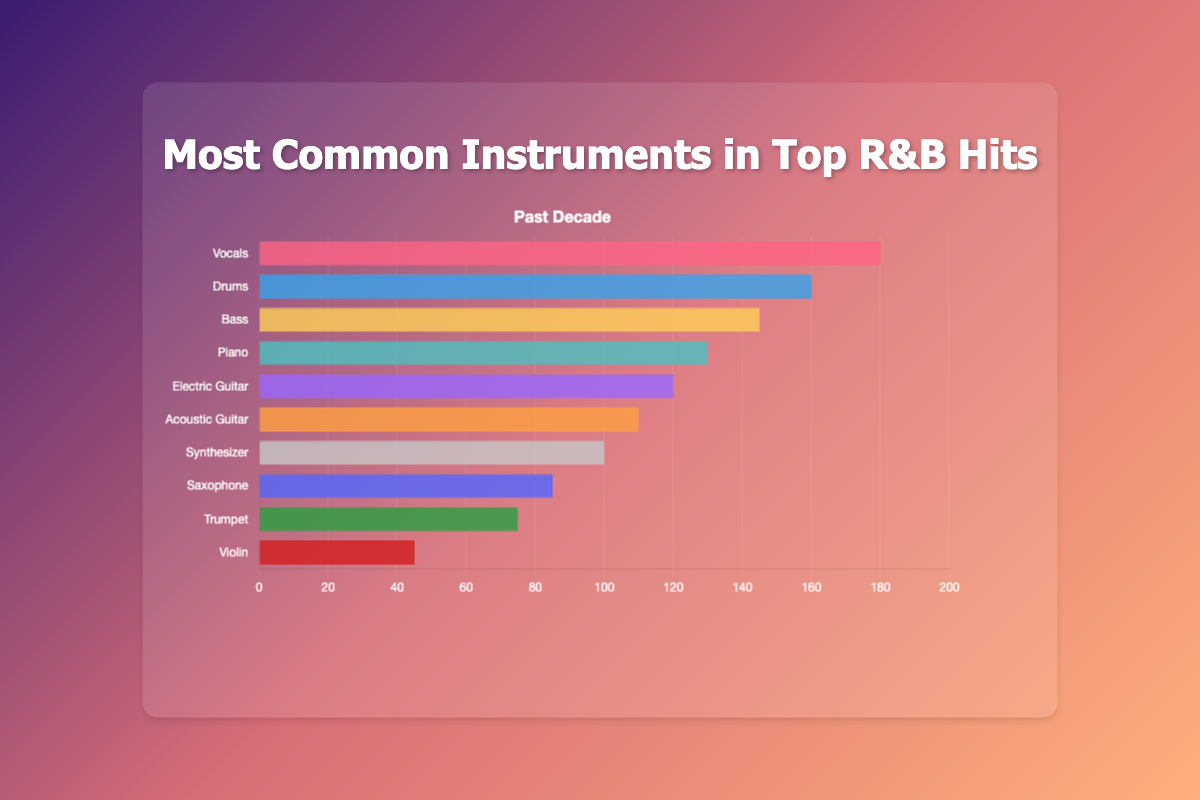Which instrument has the highest frequency in top R&B hits? The bar labeled "Vocals" has the longest length, indicating it has the highest frequency at 180.
Answer: Vocals What is the total frequency of the Bass and Piano combined? The Bass has a frequency of 145, and the Piano has a frequency of 130. Adding them gives 145 + 130 = 275.
Answer: 275 How many more times is the Electric Guitar used compared to the Violin? The Electric Guitar's frequency is 120, and the Violin's frequency is 45. Subtracting 45 from 120 gives 120 - 45 = 75.
Answer: 75 Which instrument appears the least frequently in the chart? The shortest bar corresponds to the Violin, with a frequency of 45.
Answer: Violin What is the average frequency of the Synthesizer, Trumpet, and Saxophone? Adding the frequencies: Synthesizer (100), Trumpet (75), and Saxophone (85) gives 100 + 75 + 85 = 260. Dividing by 3 gives 260 / 3 ≈ 86.67.
Answer: 86.67 Which has a higher frequency, Acoustic Guitar or Electric Guitar? Comparing bar lengths, the Acoustic Guitar has a frequency of 110, and the Electric Guitar has a frequency of 120.
Answer: Electric Guitar What is the difference in frequency between the Drums and the Bass? The Drums have a frequency of 160, and the Bass has a frequency of 145. The difference is 160 - 145 = 15.
Answer: 15 What is the combined frequency of all instruments? Summing all frequencies: Vocals (180), Drums (160), Bass (145), Piano (130), Electric Guitar (120), Acoustic Guitar (110), Synthesizer (100), Saxophone (85), Trumpet (75), Violin (45) gives a total of 1150.
Answer: 1150 Which instrument is more frequently used, the Trumpet or the Saxophone, and by how much? The Trumpet has a frequency of 75, and the Saxophone has a frequency of 85. Subtracting 75 from 85 gives 85 - 75 = 10.
Answer: Saxophone, by 10 What is the median frequency of the instruments? Ordering the frequencies: 45, 75, 85, 100, 110, 120, 130, 145, 160, 180. The median is the average of the 5th and 6th values: (110 + 120) / 2 = 115.
Answer: 115 